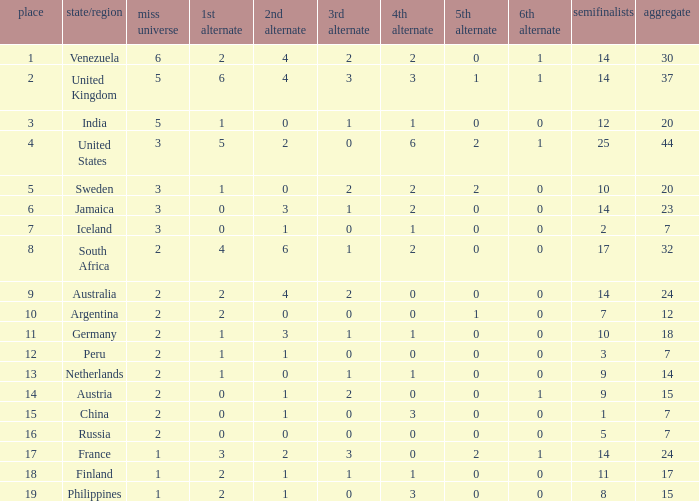Could you parse the entire table? {'header': ['place', 'state/region', 'miss universe', '1st alternate', '2nd alternate', '3rd alternate', '4th alternate', '5th alternate', '6th alternate', 'semifinalists', 'aggregate'], 'rows': [['1', 'Venezuela', '6', '2', '4', '2', '2', '0', '1', '14', '30'], ['2', 'United Kingdom', '5', '6', '4', '3', '3', '1', '1', '14', '37'], ['3', 'India', '5', '1', '0', '1', '1', '0', '0', '12', '20'], ['4', 'United States', '3', '5', '2', '0', '6', '2', '1', '25', '44'], ['5', 'Sweden', '3', '1', '0', '2', '2', '2', '0', '10', '20'], ['6', 'Jamaica', '3', '0', '3', '1', '2', '0', '0', '14', '23'], ['7', 'Iceland', '3', '0', '1', '0', '1', '0', '0', '2', '7'], ['8', 'South Africa', '2', '4', '6', '1', '2', '0', '0', '17', '32'], ['9', 'Australia', '2', '2', '4', '2', '0', '0', '0', '14', '24'], ['10', 'Argentina', '2', '2', '0', '0', '0', '1', '0', '7', '12'], ['11', 'Germany', '2', '1', '3', '1', '1', '0', '0', '10', '18'], ['12', 'Peru', '2', '1', '1', '0', '0', '0', '0', '3', '7'], ['13', 'Netherlands', '2', '1', '0', '1', '1', '0', '0', '9', '14'], ['14', 'Austria', '2', '0', '1', '2', '0', '0', '1', '9', '15'], ['15', 'China', '2', '0', '1', '0', '3', '0', '0', '1', '7'], ['16', 'Russia', '2', '0', '0', '0', '0', '0', '0', '5', '7'], ['17', 'France', '1', '3', '2', '3', '0', '2', '1', '14', '24'], ['18', 'Finland', '1', '2', '1', '1', '1', '0', '0', '11', '17'], ['19', 'Philippines', '1', '2', '1', '0', '3', '0', '0', '8', '15']]} What is the United States rank? 1.0. 